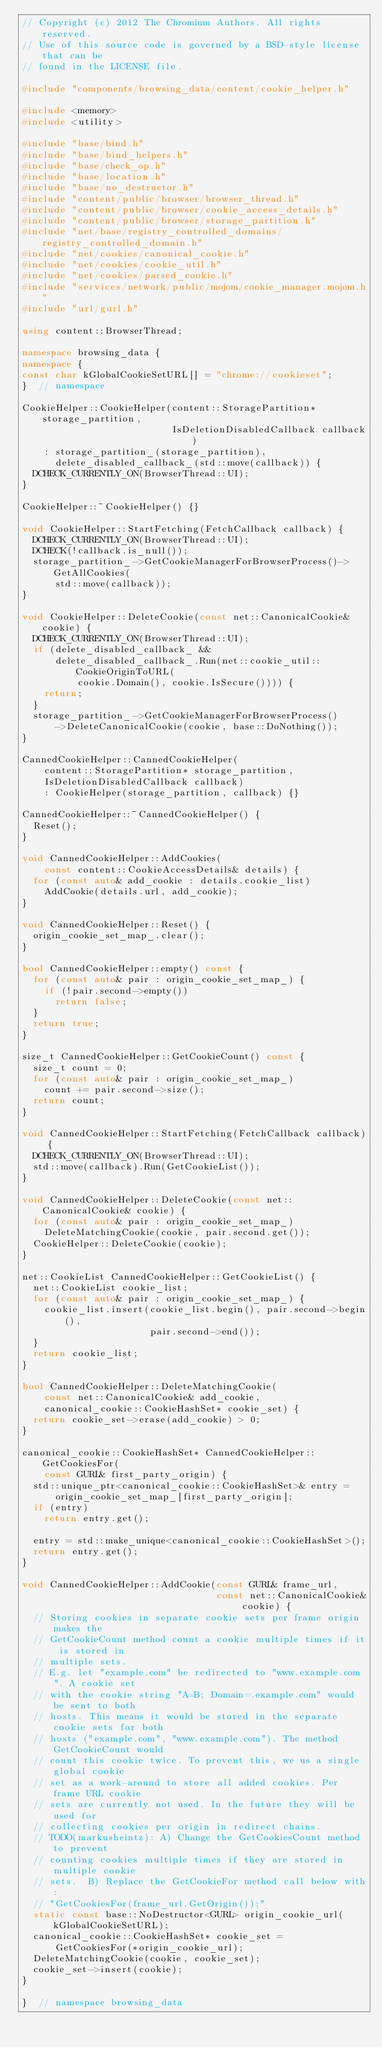Convert code to text. <code><loc_0><loc_0><loc_500><loc_500><_C++_>// Copyright (c) 2012 The Chromium Authors. All rights reserved.
// Use of this source code is governed by a BSD-style license that can be
// found in the LICENSE file.

#include "components/browsing_data/content/cookie_helper.h"

#include <memory>
#include <utility>

#include "base/bind.h"
#include "base/bind_helpers.h"
#include "base/check_op.h"
#include "base/location.h"
#include "base/no_destructor.h"
#include "content/public/browser/browser_thread.h"
#include "content/public/browser/cookie_access_details.h"
#include "content/public/browser/storage_partition.h"
#include "net/base/registry_controlled_domains/registry_controlled_domain.h"
#include "net/cookies/canonical_cookie.h"
#include "net/cookies/cookie_util.h"
#include "net/cookies/parsed_cookie.h"
#include "services/network/public/mojom/cookie_manager.mojom.h"
#include "url/gurl.h"

using content::BrowserThread;

namespace browsing_data {
namespace {
const char kGlobalCookieSetURL[] = "chrome://cookieset";
}  // namespace

CookieHelper::CookieHelper(content::StoragePartition* storage_partition,
                           IsDeletionDisabledCallback callback)
    : storage_partition_(storage_partition),
      delete_disabled_callback_(std::move(callback)) {
  DCHECK_CURRENTLY_ON(BrowserThread::UI);
}

CookieHelper::~CookieHelper() {}

void CookieHelper::StartFetching(FetchCallback callback) {
  DCHECK_CURRENTLY_ON(BrowserThread::UI);
  DCHECK(!callback.is_null());
  storage_partition_->GetCookieManagerForBrowserProcess()->GetAllCookies(
      std::move(callback));
}

void CookieHelper::DeleteCookie(const net::CanonicalCookie& cookie) {
  DCHECK_CURRENTLY_ON(BrowserThread::UI);
  if (delete_disabled_callback_ &&
      delete_disabled_callback_.Run(net::cookie_util::CookieOriginToURL(
          cookie.Domain(), cookie.IsSecure()))) {
    return;
  }
  storage_partition_->GetCookieManagerForBrowserProcess()
      ->DeleteCanonicalCookie(cookie, base::DoNothing());
}

CannedCookieHelper::CannedCookieHelper(
    content::StoragePartition* storage_partition,
    IsDeletionDisabledCallback callback)
    : CookieHelper(storage_partition, callback) {}

CannedCookieHelper::~CannedCookieHelper() {
  Reset();
}

void CannedCookieHelper::AddCookies(
    const content::CookieAccessDetails& details) {
  for (const auto& add_cookie : details.cookie_list)
    AddCookie(details.url, add_cookie);
}

void CannedCookieHelper::Reset() {
  origin_cookie_set_map_.clear();
}

bool CannedCookieHelper::empty() const {
  for (const auto& pair : origin_cookie_set_map_) {
    if (!pair.second->empty())
      return false;
  }
  return true;
}

size_t CannedCookieHelper::GetCookieCount() const {
  size_t count = 0;
  for (const auto& pair : origin_cookie_set_map_)
    count += pair.second->size();
  return count;
}

void CannedCookieHelper::StartFetching(FetchCallback callback) {
  DCHECK_CURRENTLY_ON(BrowserThread::UI);
  std::move(callback).Run(GetCookieList());
}

void CannedCookieHelper::DeleteCookie(const net::CanonicalCookie& cookie) {
  for (const auto& pair : origin_cookie_set_map_)
    DeleteMatchingCookie(cookie, pair.second.get());
  CookieHelper::DeleteCookie(cookie);
}

net::CookieList CannedCookieHelper::GetCookieList() {
  net::CookieList cookie_list;
  for (const auto& pair : origin_cookie_set_map_) {
    cookie_list.insert(cookie_list.begin(), pair.second->begin(),
                       pair.second->end());
  }
  return cookie_list;
}

bool CannedCookieHelper::DeleteMatchingCookie(
    const net::CanonicalCookie& add_cookie,
    canonical_cookie::CookieHashSet* cookie_set) {
  return cookie_set->erase(add_cookie) > 0;
}

canonical_cookie::CookieHashSet* CannedCookieHelper::GetCookiesFor(
    const GURL& first_party_origin) {
  std::unique_ptr<canonical_cookie::CookieHashSet>& entry =
      origin_cookie_set_map_[first_party_origin];
  if (entry)
    return entry.get();

  entry = std::make_unique<canonical_cookie::CookieHashSet>();
  return entry.get();
}

void CannedCookieHelper::AddCookie(const GURL& frame_url,
                                   const net::CanonicalCookie& cookie) {
  // Storing cookies in separate cookie sets per frame origin makes the
  // GetCookieCount method count a cookie multiple times if it is stored in
  // multiple sets.
  // E.g. let "example.com" be redirected to "www.example.com". A cookie set
  // with the cookie string "A=B; Domain=.example.com" would be sent to both
  // hosts. This means it would be stored in the separate cookie sets for both
  // hosts ("example.com", "www.example.com"). The method GetCookieCount would
  // count this cookie twice. To prevent this, we us a single global cookie
  // set as a work-around to store all added cookies. Per frame URL cookie
  // sets are currently not used. In the future they will be used for
  // collecting cookies per origin in redirect chains.
  // TODO(markusheintz): A) Change the GetCookiesCount method to prevent
  // counting cookies multiple times if they are stored in multiple cookie
  // sets.  B) Replace the GetCookieFor method call below with:
  // "GetCookiesFor(frame_url.GetOrigin());"
  static const base::NoDestructor<GURL> origin_cookie_url(kGlobalCookieSetURL);
  canonical_cookie::CookieHashSet* cookie_set =
      GetCookiesFor(*origin_cookie_url);
  DeleteMatchingCookie(cookie, cookie_set);
  cookie_set->insert(cookie);
}

}  // namespace browsing_data
</code> 